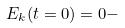<formula> <loc_0><loc_0><loc_500><loc_500>E _ { k } ( t = 0 ) = 0 -</formula> 